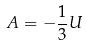Convert formula to latex. <formula><loc_0><loc_0><loc_500><loc_500>A = - \frac { 1 } { 3 } U</formula> 